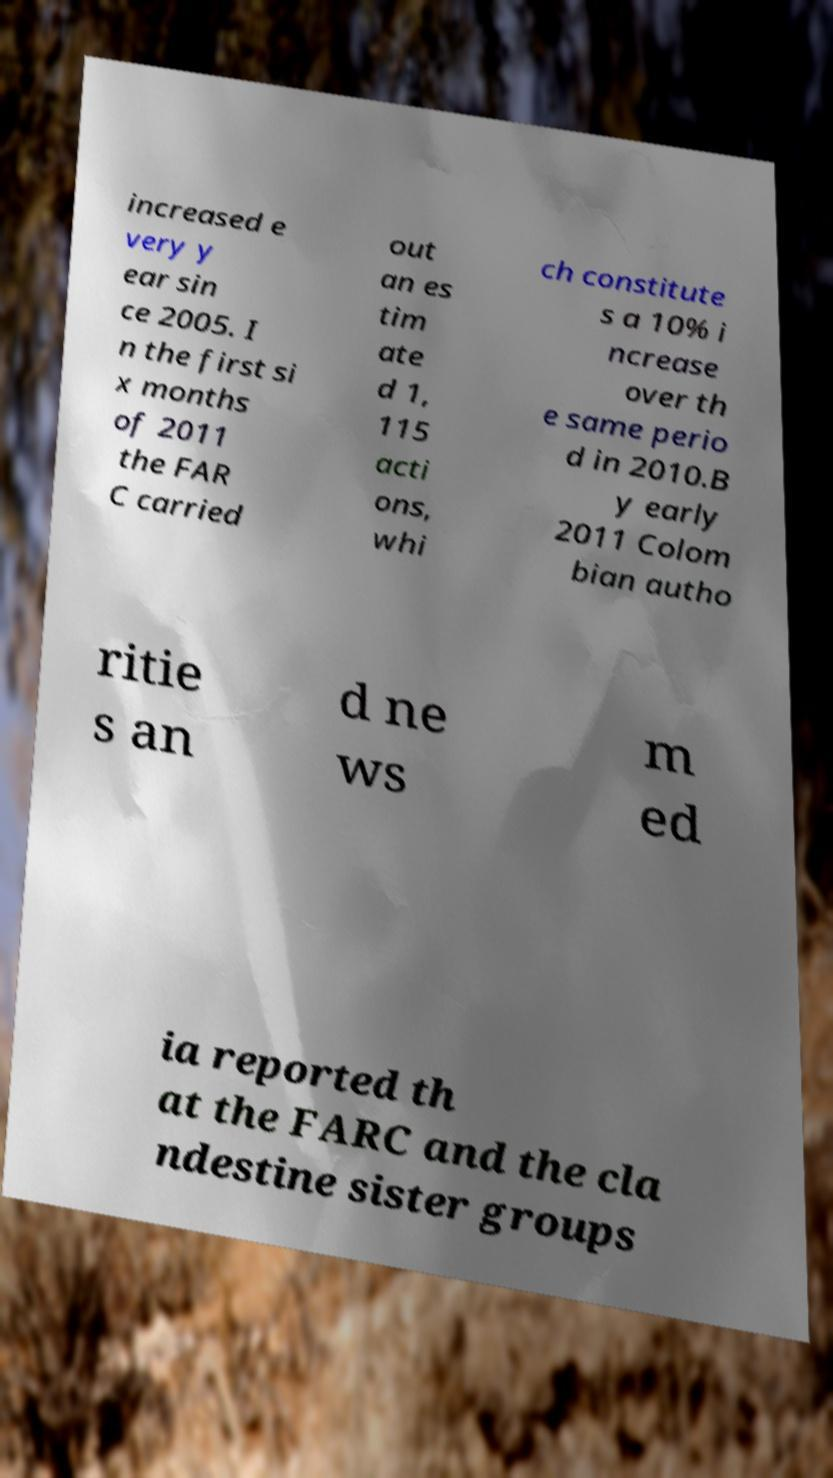Can you accurately transcribe the text from the provided image for me? increased e very y ear sin ce 2005. I n the first si x months of 2011 the FAR C carried out an es tim ate d 1, 115 acti ons, whi ch constitute s a 10% i ncrease over th e same perio d in 2010.B y early 2011 Colom bian autho ritie s an d ne ws m ed ia reported th at the FARC and the cla ndestine sister groups 